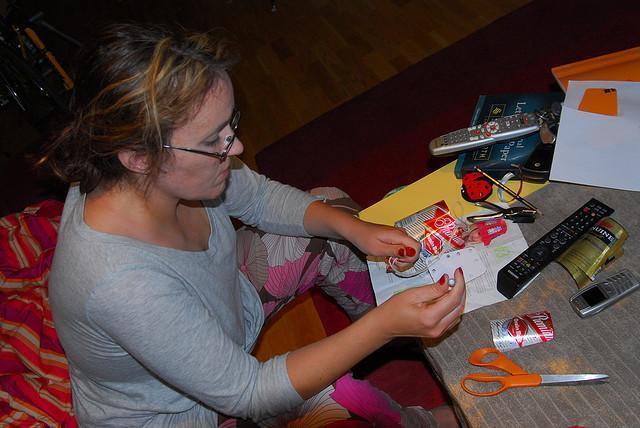How many remotes are on the table?
Give a very brief answer. 2. How many pencils are on the table?
Give a very brief answer. 1. How many people in the photo?
Give a very brief answer. 1. How many books can you see?
Give a very brief answer. 2. How many remotes can be seen?
Give a very brief answer. 2. 